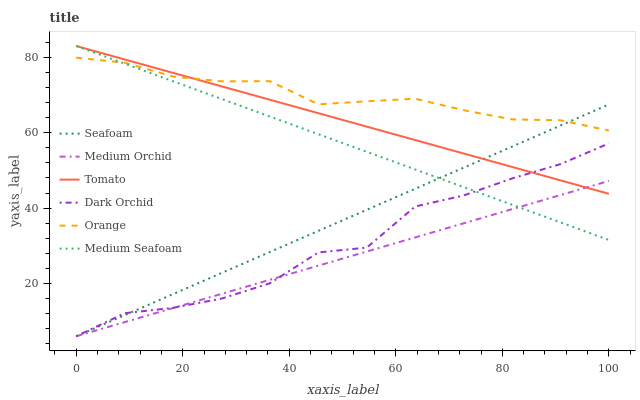Does Medium Orchid have the minimum area under the curve?
Answer yes or no. Yes. Does Orange have the maximum area under the curve?
Answer yes or no. Yes. Does Seafoam have the minimum area under the curve?
Answer yes or no. No. Does Seafoam have the maximum area under the curve?
Answer yes or no. No. Is Medium Orchid the smoothest?
Answer yes or no. Yes. Is Dark Orchid the roughest?
Answer yes or no. Yes. Is Seafoam the smoothest?
Answer yes or no. No. Is Seafoam the roughest?
Answer yes or no. No. Does Medium Orchid have the lowest value?
Answer yes or no. Yes. Does Orange have the lowest value?
Answer yes or no. No. Does Medium Seafoam have the highest value?
Answer yes or no. Yes. Does Seafoam have the highest value?
Answer yes or no. No. Is Dark Orchid less than Orange?
Answer yes or no. Yes. Is Orange greater than Medium Orchid?
Answer yes or no. Yes. Does Medium Orchid intersect Medium Seafoam?
Answer yes or no. Yes. Is Medium Orchid less than Medium Seafoam?
Answer yes or no. No. Is Medium Orchid greater than Medium Seafoam?
Answer yes or no. No. Does Dark Orchid intersect Orange?
Answer yes or no. No. 